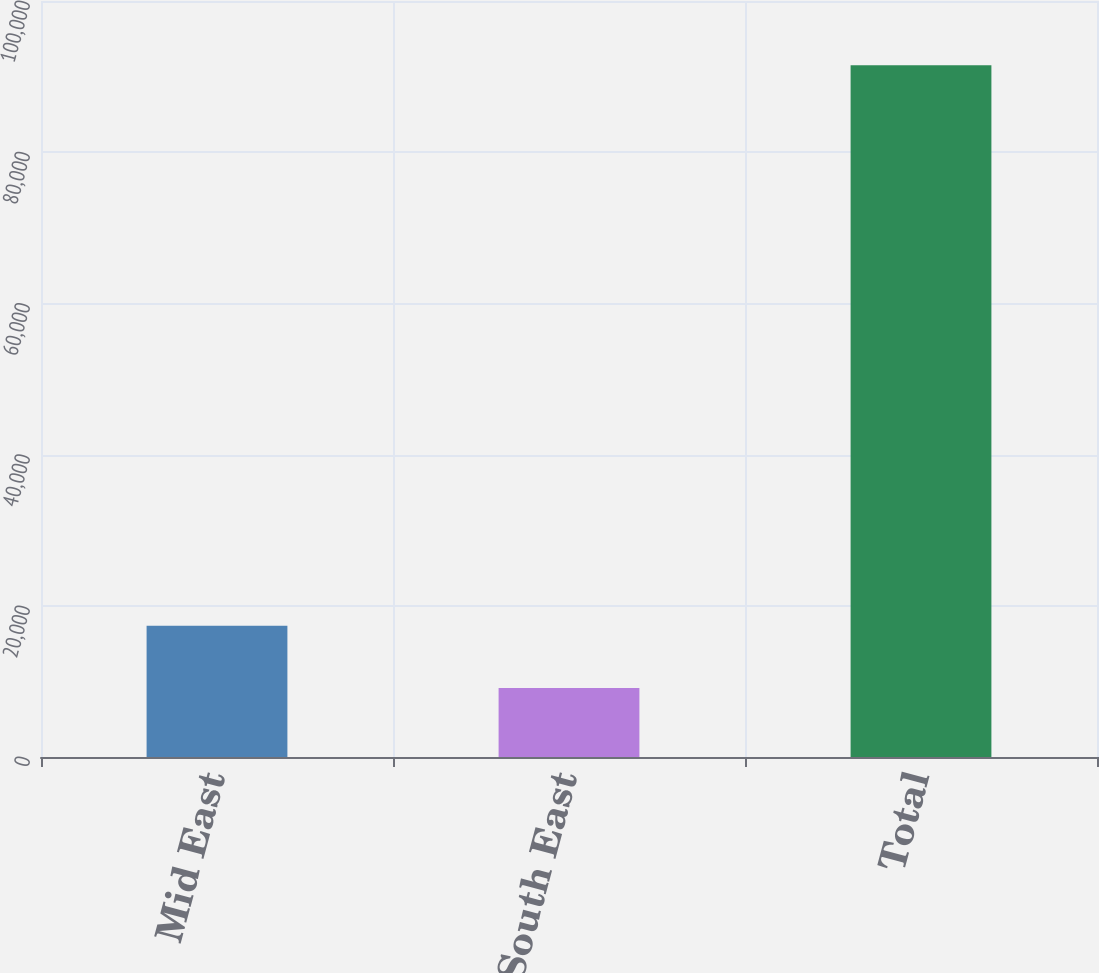Convert chart. <chart><loc_0><loc_0><loc_500><loc_500><bar_chart><fcel>Mid East<fcel>South East<fcel>Total<nl><fcel>17374<fcel>9137<fcel>91507<nl></chart> 